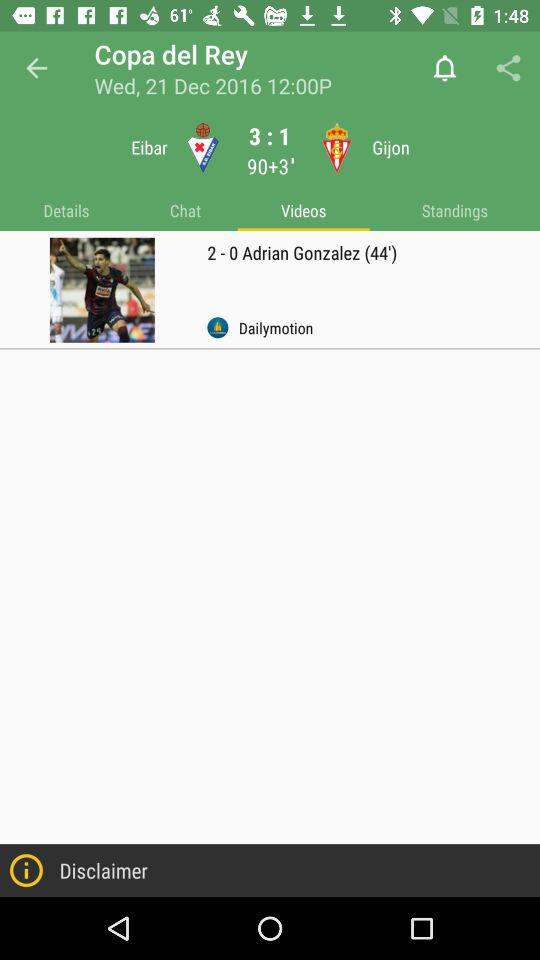How many more goals did Eibar score than Gijon?
Answer the question using a single word or phrase. 2 